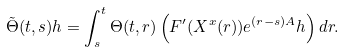Convert formula to latex. <formula><loc_0><loc_0><loc_500><loc_500>\tilde { \Theta } ( t , s ) h = \int _ { s } ^ { t } \Theta ( t , r ) \left ( F ^ { \prime } ( X ^ { x } ( r ) ) e ^ { ( r - s ) A } h \right ) d r .</formula> 